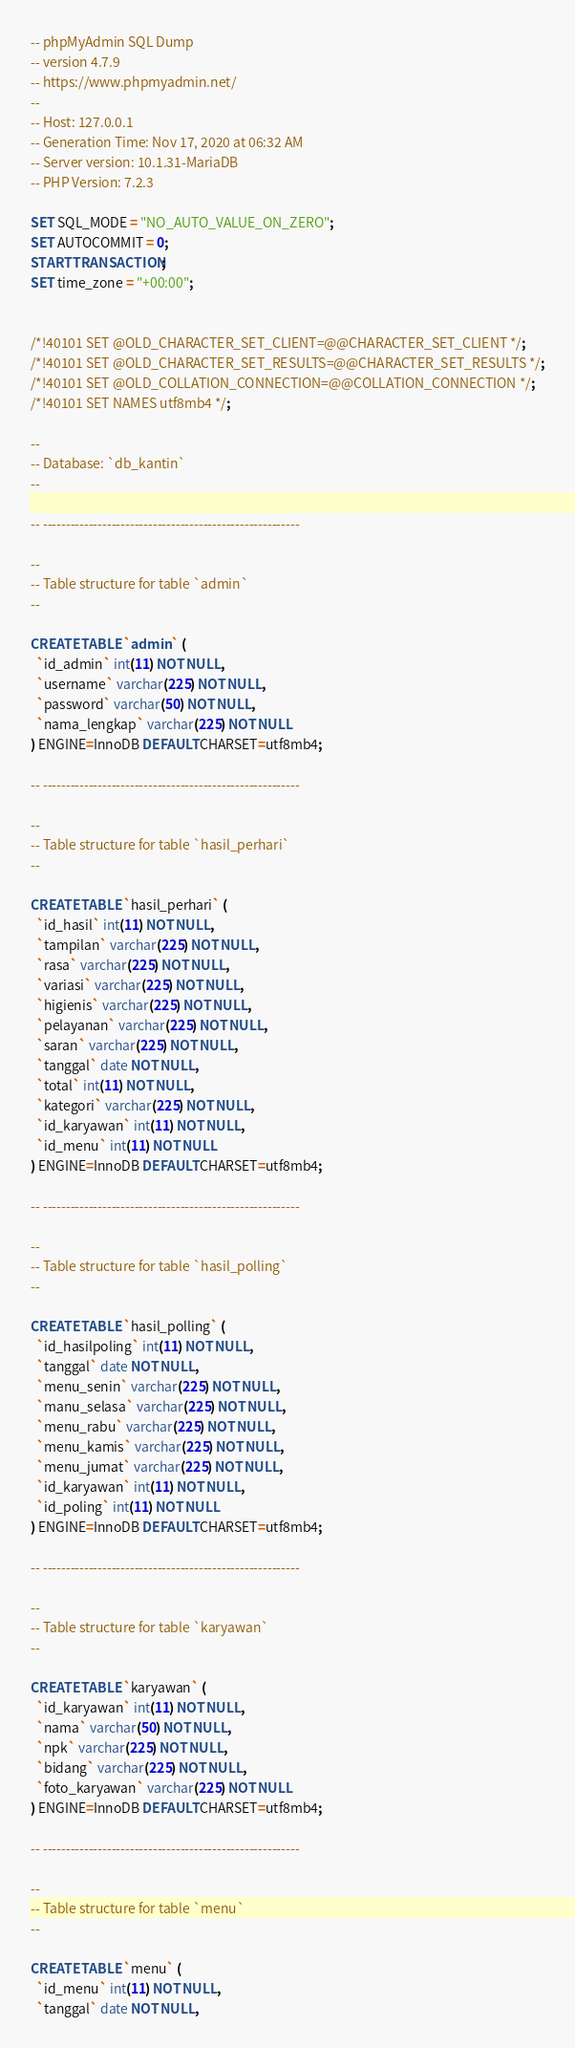<code> <loc_0><loc_0><loc_500><loc_500><_SQL_>-- phpMyAdmin SQL Dump
-- version 4.7.9
-- https://www.phpmyadmin.net/
--
-- Host: 127.0.0.1
-- Generation Time: Nov 17, 2020 at 06:32 AM
-- Server version: 10.1.31-MariaDB
-- PHP Version: 7.2.3

SET SQL_MODE = "NO_AUTO_VALUE_ON_ZERO";
SET AUTOCOMMIT = 0;
START TRANSACTION;
SET time_zone = "+00:00";


/*!40101 SET @OLD_CHARACTER_SET_CLIENT=@@CHARACTER_SET_CLIENT */;
/*!40101 SET @OLD_CHARACTER_SET_RESULTS=@@CHARACTER_SET_RESULTS */;
/*!40101 SET @OLD_COLLATION_CONNECTION=@@COLLATION_CONNECTION */;
/*!40101 SET NAMES utf8mb4 */;

--
-- Database: `db_kantin`
--

-- --------------------------------------------------------

--
-- Table structure for table `admin`
--

CREATE TABLE `admin` (
  `id_admin` int(11) NOT NULL,
  `username` varchar(225) NOT NULL,
  `password` varchar(50) NOT NULL,
  `nama_lengkap` varchar(225) NOT NULL
) ENGINE=InnoDB DEFAULT CHARSET=utf8mb4;

-- --------------------------------------------------------

--
-- Table structure for table `hasil_perhari`
--

CREATE TABLE `hasil_perhari` (
  `id_hasil` int(11) NOT NULL,
  `tampilan` varchar(225) NOT NULL,
  `rasa` varchar(225) NOT NULL,
  `variasi` varchar(225) NOT NULL,
  `higienis` varchar(225) NOT NULL,
  `pelayanan` varchar(225) NOT NULL,
  `saran` varchar(225) NOT NULL,
  `tanggal` date NOT NULL,
  `total` int(11) NOT NULL,
  `kategori` varchar(225) NOT NULL,
  `id_karyawan` int(11) NOT NULL,
  `id_menu` int(11) NOT NULL
) ENGINE=InnoDB DEFAULT CHARSET=utf8mb4;

-- --------------------------------------------------------

--
-- Table structure for table `hasil_polling`
--

CREATE TABLE `hasil_polling` (
  `id_hasilpoling` int(11) NOT NULL,
  `tanggal` date NOT NULL,
  `menu_senin` varchar(225) NOT NULL,
  `manu_selasa` varchar(225) NOT NULL,
  `menu_rabu` varchar(225) NOT NULL,
  `menu_kamis` varchar(225) NOT NULL,
  `menu_jumat` varchar(225) NOT NULL,
  `id_karyawan` int(11) NOT NULL,
  `id_poling` int(11) NOT NULL
) ENGINE=InnoDB DEFAULT CHARSET=utf8mb4;

-- --------------------------------------------------------

--
-- Table structure for table `karyawan`
--

CREATE TABLE `karyawan` (
  `id_karyawan` int(11) NOT NULL,
  `nama` varchar(50) NOT NULL,
  `npk` varchar(225) NOT NULL,
  `bidang` varchar(225) NOT NULL,
  `foto_karyawan` varchar(225) NOT NULL
) ENGINE=InnoDB DEFAULT CHARSET=utf8mb4;

-- --------------------------------------------------------

--
-- Table structure for table `menu`
--

CREATE TABLE `menu` (
  `id_menu` int(11) NOT NULL,
  `tanggal` date NOT NULL,</code> 